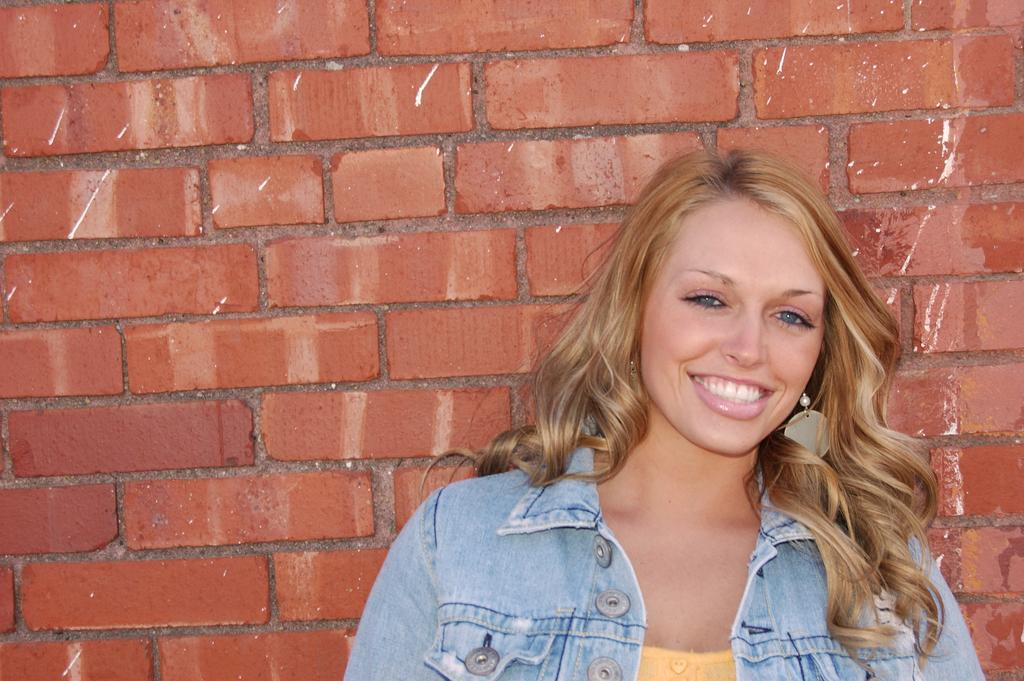Who is present in the image? A: There is a woman in the picture. What is the woman's facial expression? The woman is smiling. What can be seen in the background of the image? There is a brick wall in the background of the picture. What type of cheese is on the plate next to the woman in the image? There is no cheese or plate present in the image; it only features a woman and a brick wall in the background. 